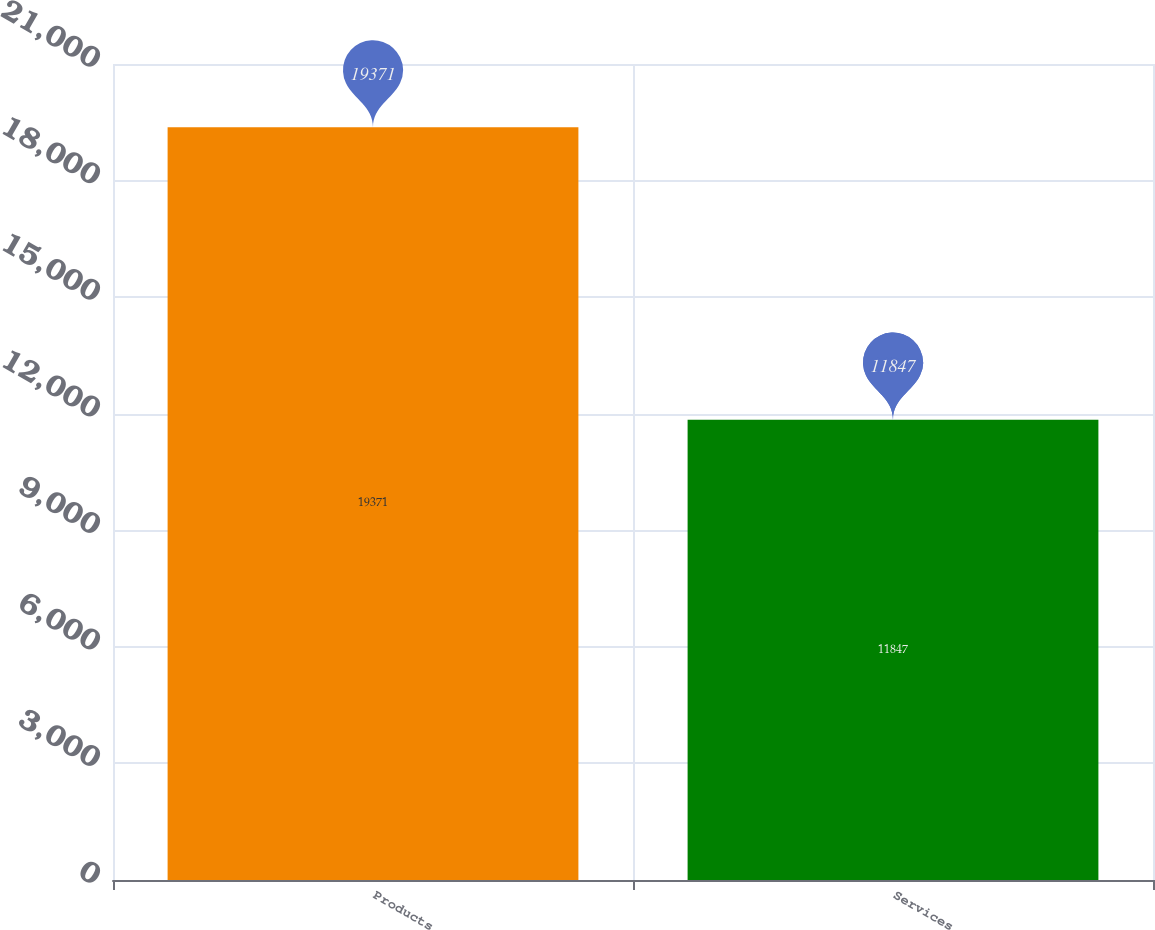Convert chart to OTSL. <chart><loc_0><loc_0><loc_500><loc_500><bar_chart><fcel>Products<fcel>Services<nl><fcel>19371<fcel>11847<nl></chart> 